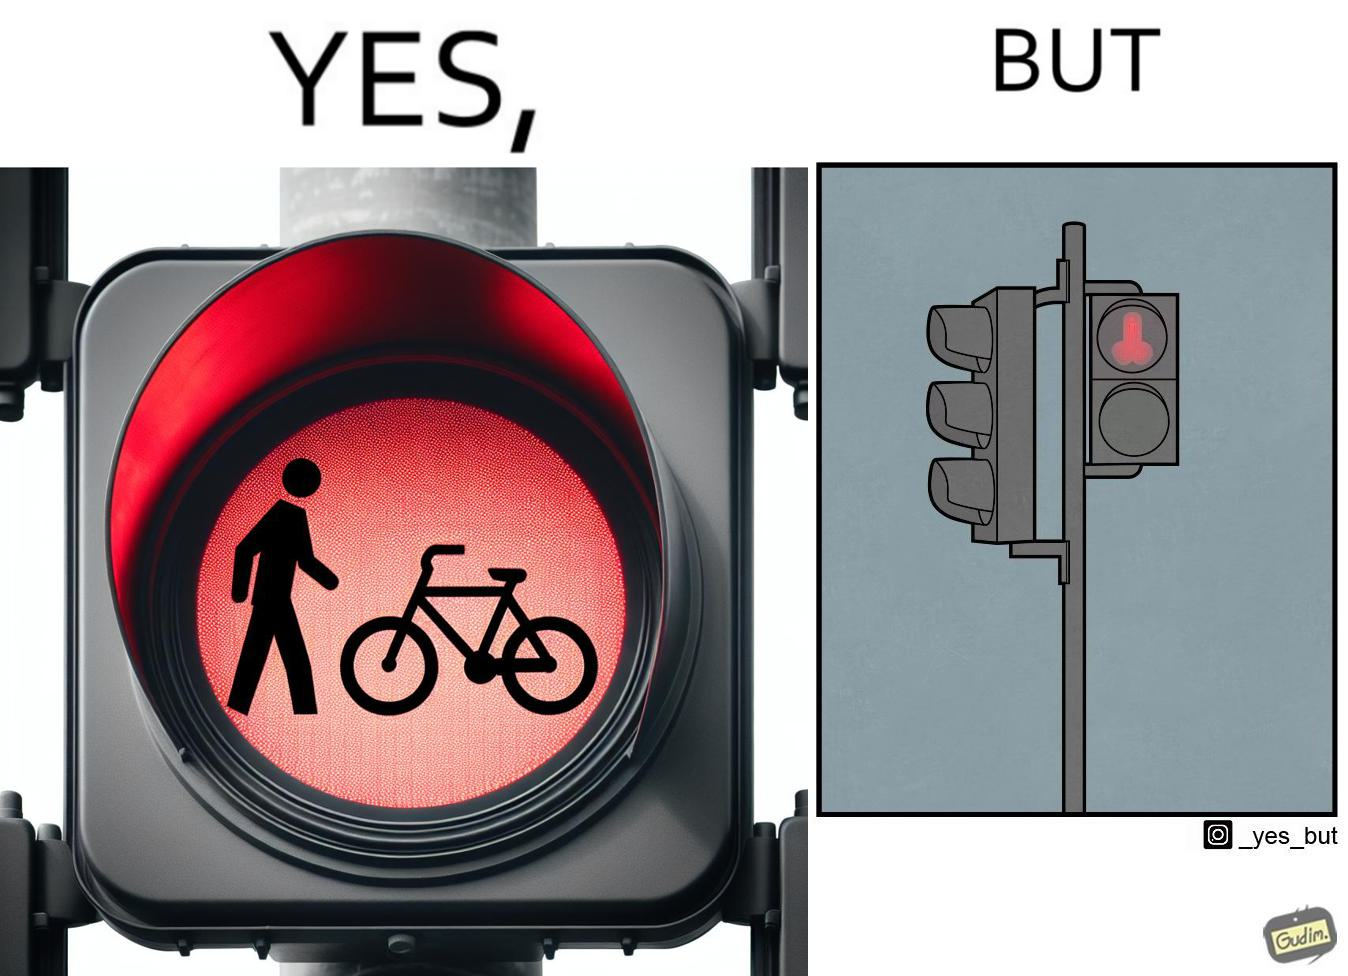Explain why this image is satirical. This image is funny because images of very regular things - a stick figure and a bicycle, get converted into  looking phallic from a distance. 